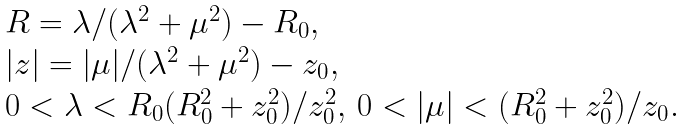Convert formula to latex. <formula><loc_0><loc_0><loc_500><loc_500>\begin{array} { l } R = \lambda / ( \lambda ^ { 2 } + \mu ^ { 2 } ) - R _ { 0 } , \\ | z | = | \mu | / ( \lambda ^ { 2 } + \mu ^ { 2 } ) - z _ { 0 } , \\ 0 < \lambda < R _ { 0 } ( R _ { 0 } ^ { 2 } + z _ { 0 } ^ { 2 } ) / z _ { 0 } ^ { 2 } , \, 0 < | \mu | < ( R _ { 0 } ^ { 2 } + z _ { 0 } ^ { 2 } ) / z _ { 0 } . \end{array}</formula> 